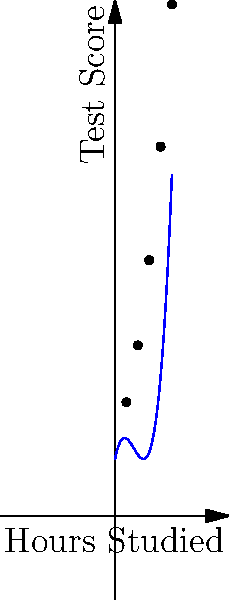As part of a study on the relationship between study time and test performance, you've collected data from your classmates. The scatter plot shows the relationship between hours studied and test scores. Which degree polynomial would best fit this data, and what does this imply about the relationship between study time and test performance? Let's approach this step-by-step:

1) First, observe the shape of the scatter plot. The points don't follow a straight line or a simple curve.

2) The curve appears to have one turning point (where it changes from decreasing to increasing), which suggests at least a cubic (3rd degree) polynomial.

3) A quadratic (2nd degree) polynomial would only have one turn and couldn't capture the complexity of this relationship.

4) A 4th degree or higher polynomial could fit the data, but it might overfit and not generalize well to new data.

5) Therefore, a 3rd degree (cubic) polynomial is likely the best fit for this data.

6) The shape of the curve implies:
   - Initially, a small increase in study time yields little improvement in test scores.
   - There's a "sweet spot" where additional study time significantly improves scores.
   - Eventually, there are diminishing returns, where more study time produces smaller improvements.

7) This relationship makes sense in real life: when you first start studying, you're still getting organized. Once you get into a groove, you learn a lot quickly. But after many hours, fatigue sets in and learning slows down.
Answer: 3rd degree polynomial; non-linear relationship with diminishing returns 